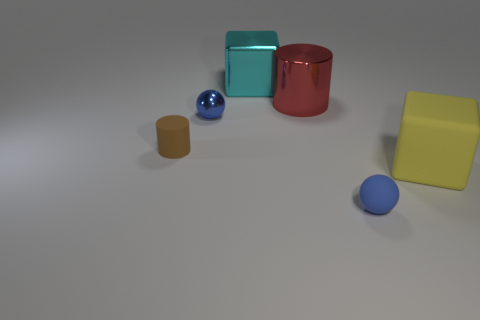Add 3 blue matte things. How many objects exist? 9 Subtract 1 balls. How many balls are left? 1 Subtract all cylinders. How many objects are left? 4 Subtract all green spheres. Subtract all cyan blocks. How many spheres are left? 2 Subtract all green blocks. How many red cylinders are left? 1 Subtract all tiny rubber things. Subtract all big gray spheres. How many objects are left? 4 Add 6 small blue objects. How many small blue objects are left? 8 Add 5 blue things. How many blue things exist? 7 Subtract 1 yellow cubes. How many objects are left? 5 